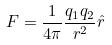Convert formula to latex. <formula><loc_0><loc_0><loc_500><loc_500>F = \frac { 1 } { 4 \pi } \frac { q _ { 1 } q _ { 2 } } { r ^ { 2 } } \hat { r }</formula> 